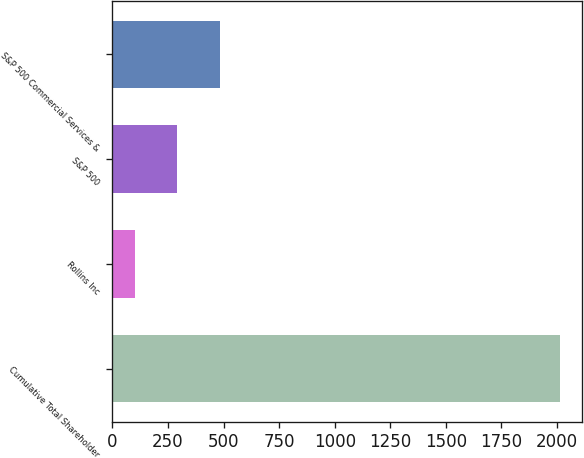<chart> <loc_0><loc_0><loc_500><loc_500><bar_chart><fcel>Cumulative Total Shareholder<fcel>Rollins Inc<fcel>S&P 500<fcel>S&P 500 Commercial Services &<nl><fcel>2013<fcel>100<fcel>291.3<fcel>482.6<nl></chart> 